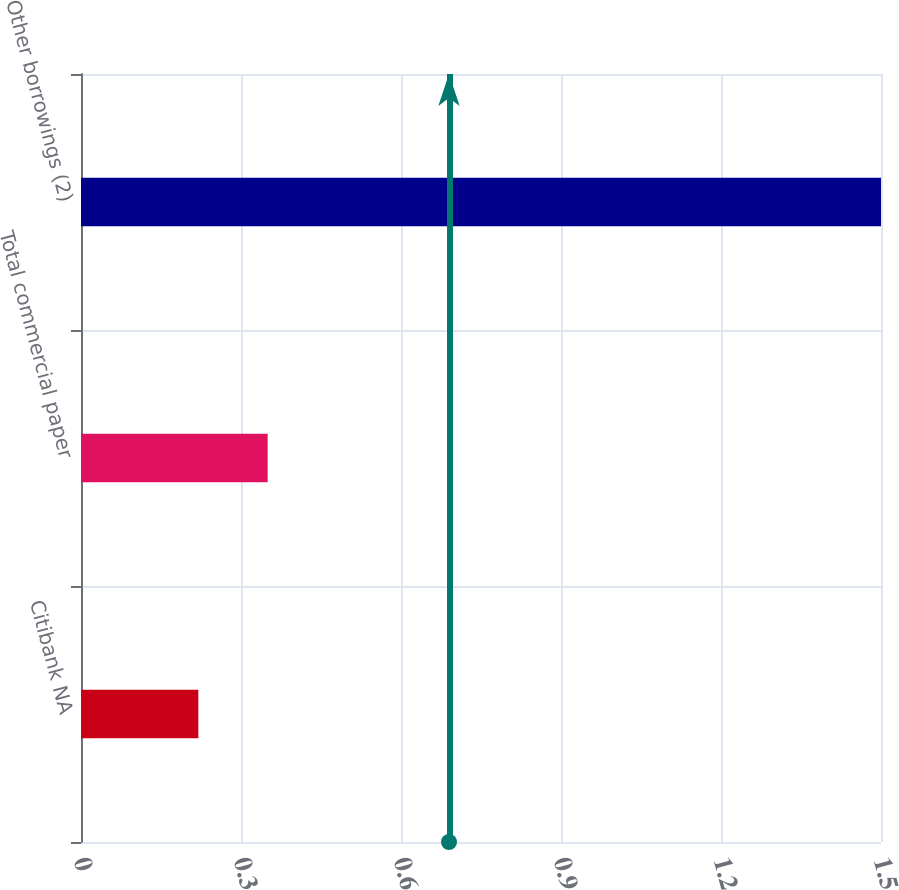<chart> <loc_0><loc_0><loc_500><loc_500><bar_chart><fcel>Citibank NA<fcel>Total commercial paper<fcel>Other borrowings (2)<nl><fcel>0.22<fcel>0.35<fcel>1.5<nl></chart> 